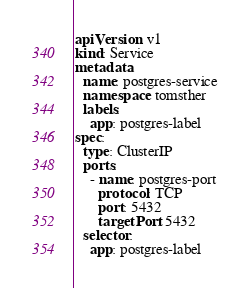<code> <loc_0><loc_0><loc_500><loc_500><_YAML_>apiVersion: v1
kind: Service
metadata:
  name: postgres-service
  namespace: tomsther
  labels:
    app: postgres-label
spec:
  type: ClusterIP
  ports:
    - name: postgres-port
      protocol: TCP
      port: 5432
      targetPort: 5432
  selector:
    app: postgres-label
</code> 